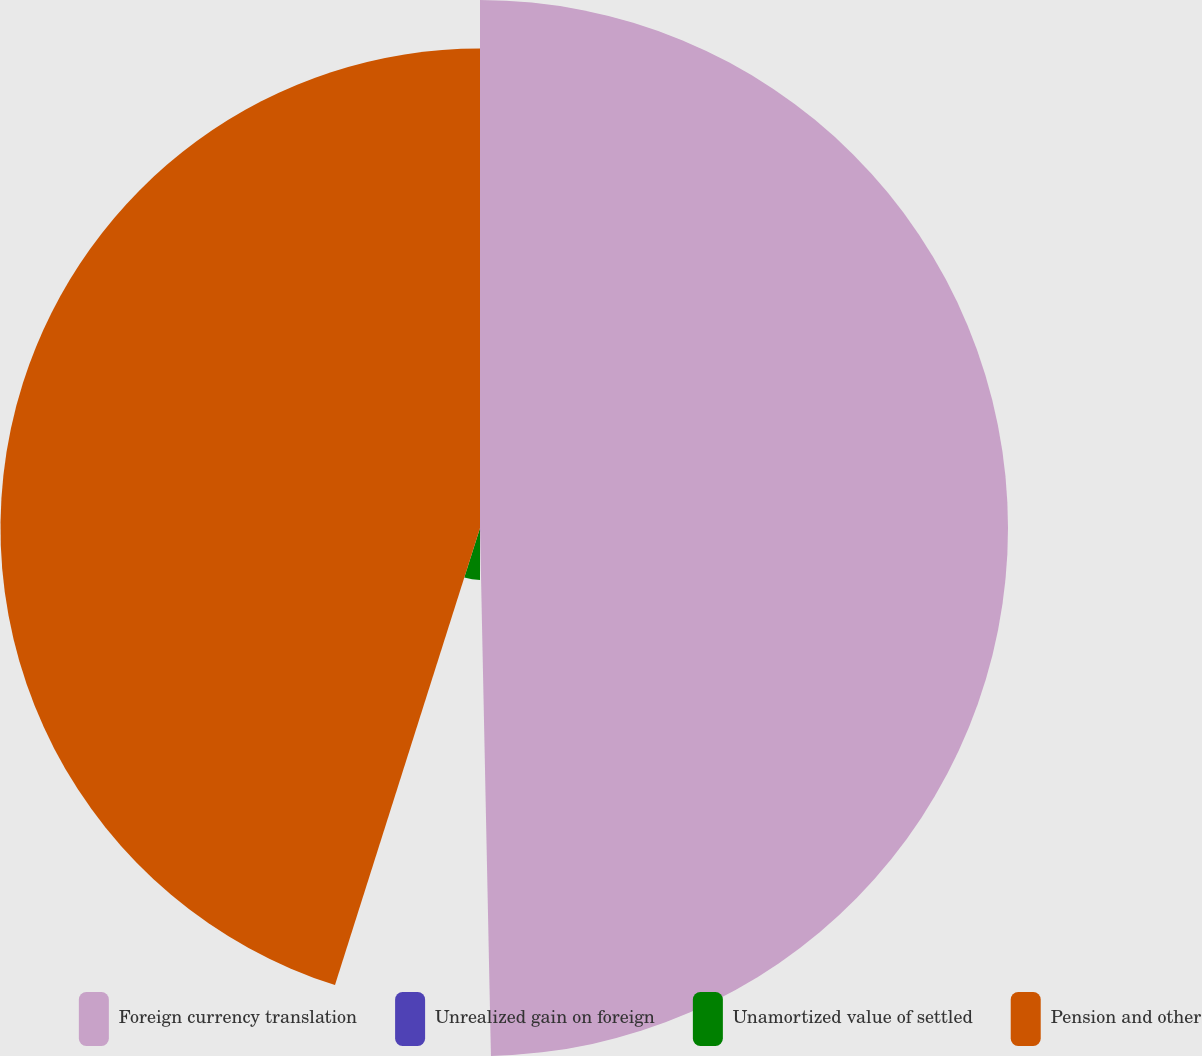Convert chart to OTSL. <chart><loc_0><loc_0><loc_500><loc_500><pie_chart><fcel>Foreign currency translation<fcel>Unrealized gain on foreign<fcel>Unamortized value of settled<fcel>Pension and other<nl><fcel>49.67%<fcel>0.33%<fcel>4.89%<fcel>45.11%<nl></chart> 